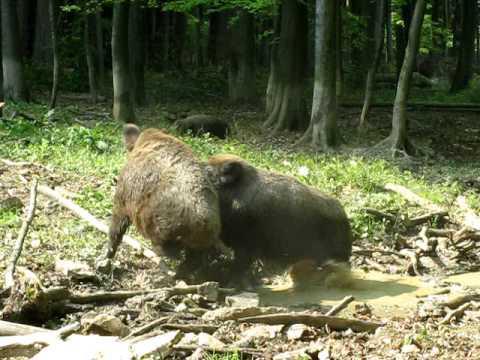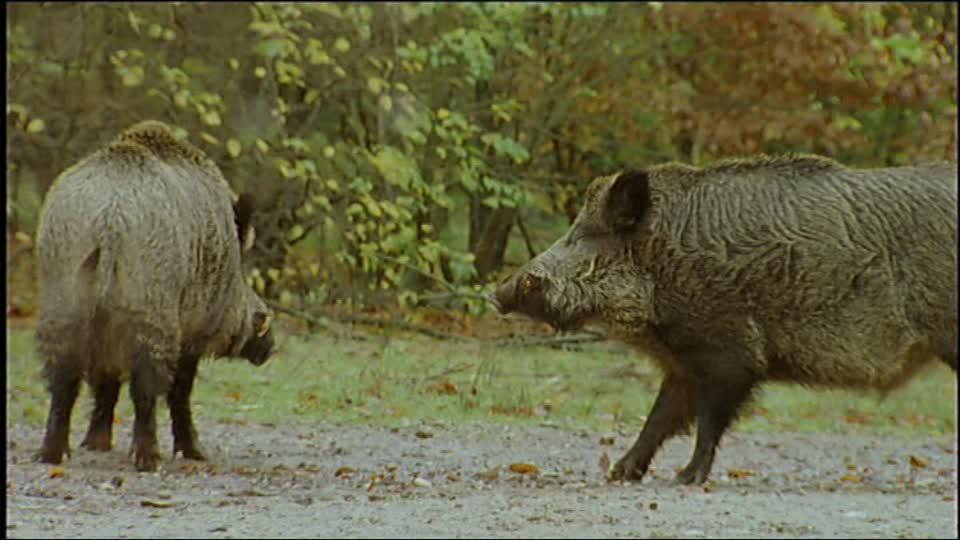The first image is the image on the left, the second image is the image on the right. Analyze the images presented: Is the assertion "The right image shows at least three boars." valid? Answer yes or no. No. 